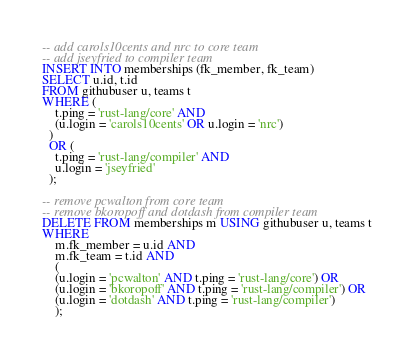<code> <loc_0><loc_0><loc_500><loc_500><_SQL_>-- add carols10cents and nrc to core team
-- add jseyfried to compiler team
INSERT INTO memberships (fk_member, fk_team)
SELECT u.id, t.id
FROM githubuser u, teams t
WHERE (
    t.ping = 'rust-lang/core' AND
    (u.login = 'carols10cents' OR u.login = 'nrc')
  )
  OR (
    t.ping = 'rust-lang/compiler' AND
    u.login = 'jseyfried'
  );

-- remove pcwalton from core team
-- remove bkoropoff and dotdash from compiler team
DELETE FROM memberships m USING githubuser u, teams t
WHERE
    m.fk_member = u.id AND
    m.fk_team = t.id AND
    (
    (u.login = 'pcwalton' AND t.ping = 'rust-lang/core') OR
    (u.login = 'bkoropoff' AND t.ping = 'rust-lang/compiler') OR
    (u.login = 'dotdash' AND t.ping = 'rust-lang/compiler')
    );
</code> 